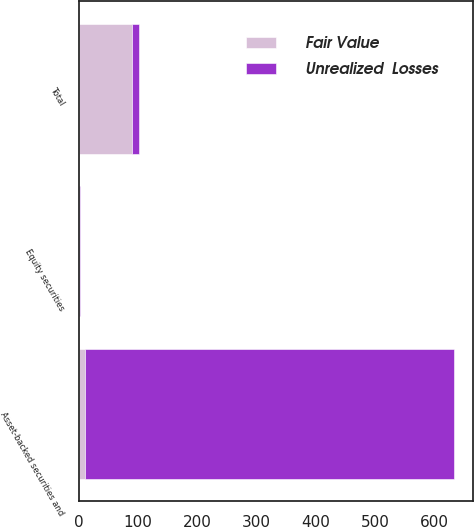<chart> <loc_0><loc_0><loc_500><loc_500><stacked_bar_chart><ecel><fcel>Asset-backed securities and<fcel>Equity securities<fcel>Total<nl><fcel>Unrealized  Losses<fcel>623<fcel>1<fcel>11<nl><fcel>Fair Value<fcel>11<fcel>1<fcel>90<nl></chart> 